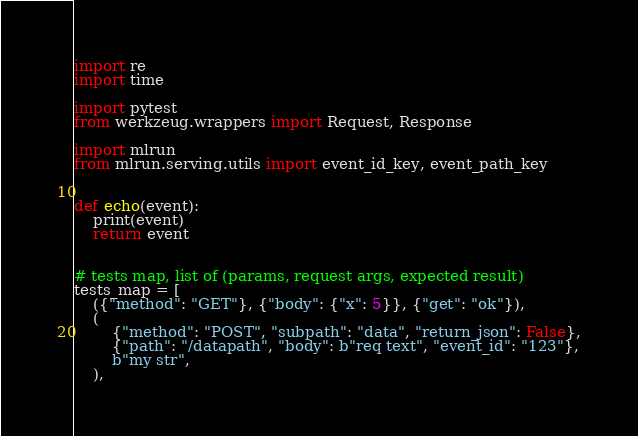<code> <loc_0><loc_0><loc_500><loc_500><_Python_>import re
import time

import pytest
from werkzeug.wrappers import Request, Response

import mlrun
from mlrun.serving.utils import event_id_key, event_path_key


def echo(event):
    print(event)
    return event


# tests map, list of (params, request args, expected result)
tests_map = [
    ({"method": "GET"}, {"body": {"x": 5}}, {"get": "ok"}),
    (
        {"method": "POST", "subpath": "data", "return_json": False},
        {"path": "/datapath", "body": b"req text", "event_id": "123"},
        b"my str",
    ),</code> 